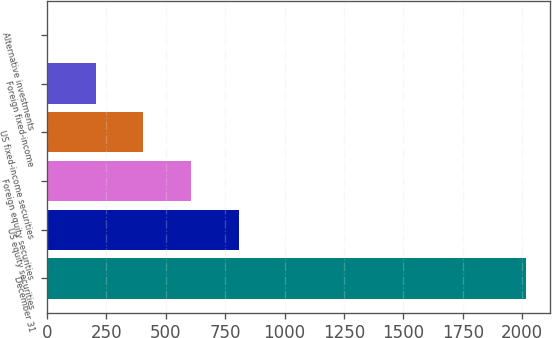Convert chart. <chart><loc_0><loc_0><loc_500><loc_500><bar_chart><fcel>December 31<fcel>US equity securities<fcel>Foreign equity securities<fcel>US fixed-income securities<fcel>Foreign fixed-income<fcel>Alternative investments<nl><fcel>2014<fcel>808.6<fcel>607.7<fcel>406.8<fcel>205.9<fcel>5<nl></chart> 